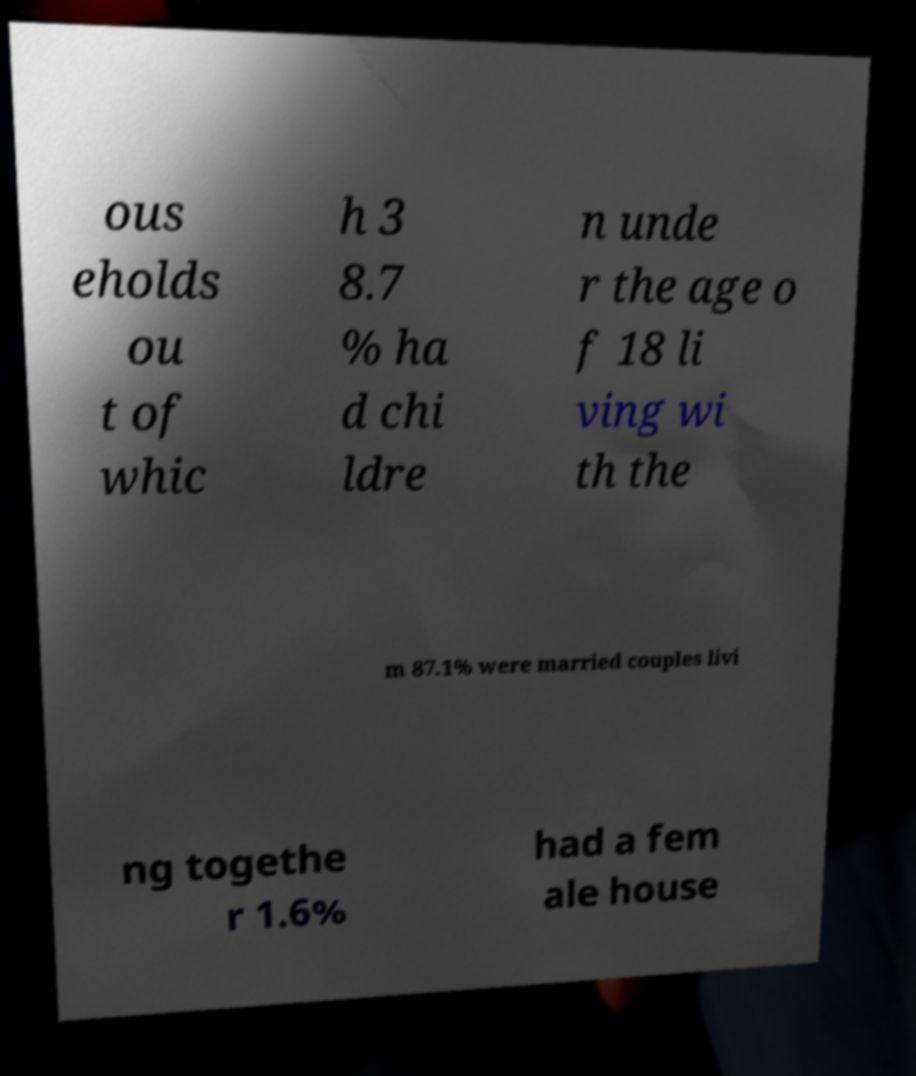There's text embedded in this image that I need extracted. Can you transcribe it verbatim? ous eholds ou t of whic h 3 8.7 % ha d chi ldre n unde r the age o f 18 li ving wi th the m 87.1% were married couples livi ng togethe r 1.6% had a fem ale house 